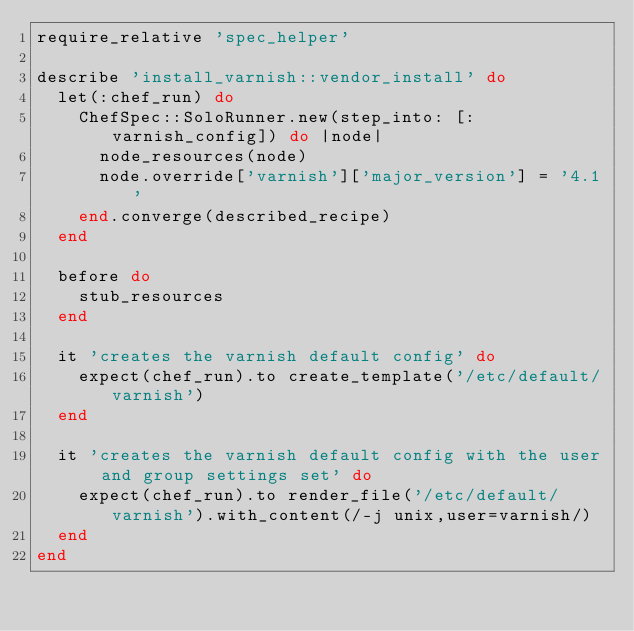Convert code to text. <code><loc_0><loc_0><loc_500><loc_500><_Ruby_>require_relative 'spec_helper'

describe 'install_varnish::vendor_install' do
  let(:chef_run) do
    ChefSpec::SoloRunner.new(step_into: [:varnish_config]) do |node|
      node_resources(node)
      node.override['varnish']['major_version'] = '4.1'
    end.converge(described_recipe)
  end

  before do
    stub_resources
  end

  it 'creates the varnish default config' do
    expect(chef_run).to create_template('/etc/default/varnish')
  end

  it 'creates the varnish default config with the user and group settings set' do
    expect(chef_run).to render_file('/etc/default/varnish').with_content(/-j unix,user=varnish/)
  end
end
</code> 